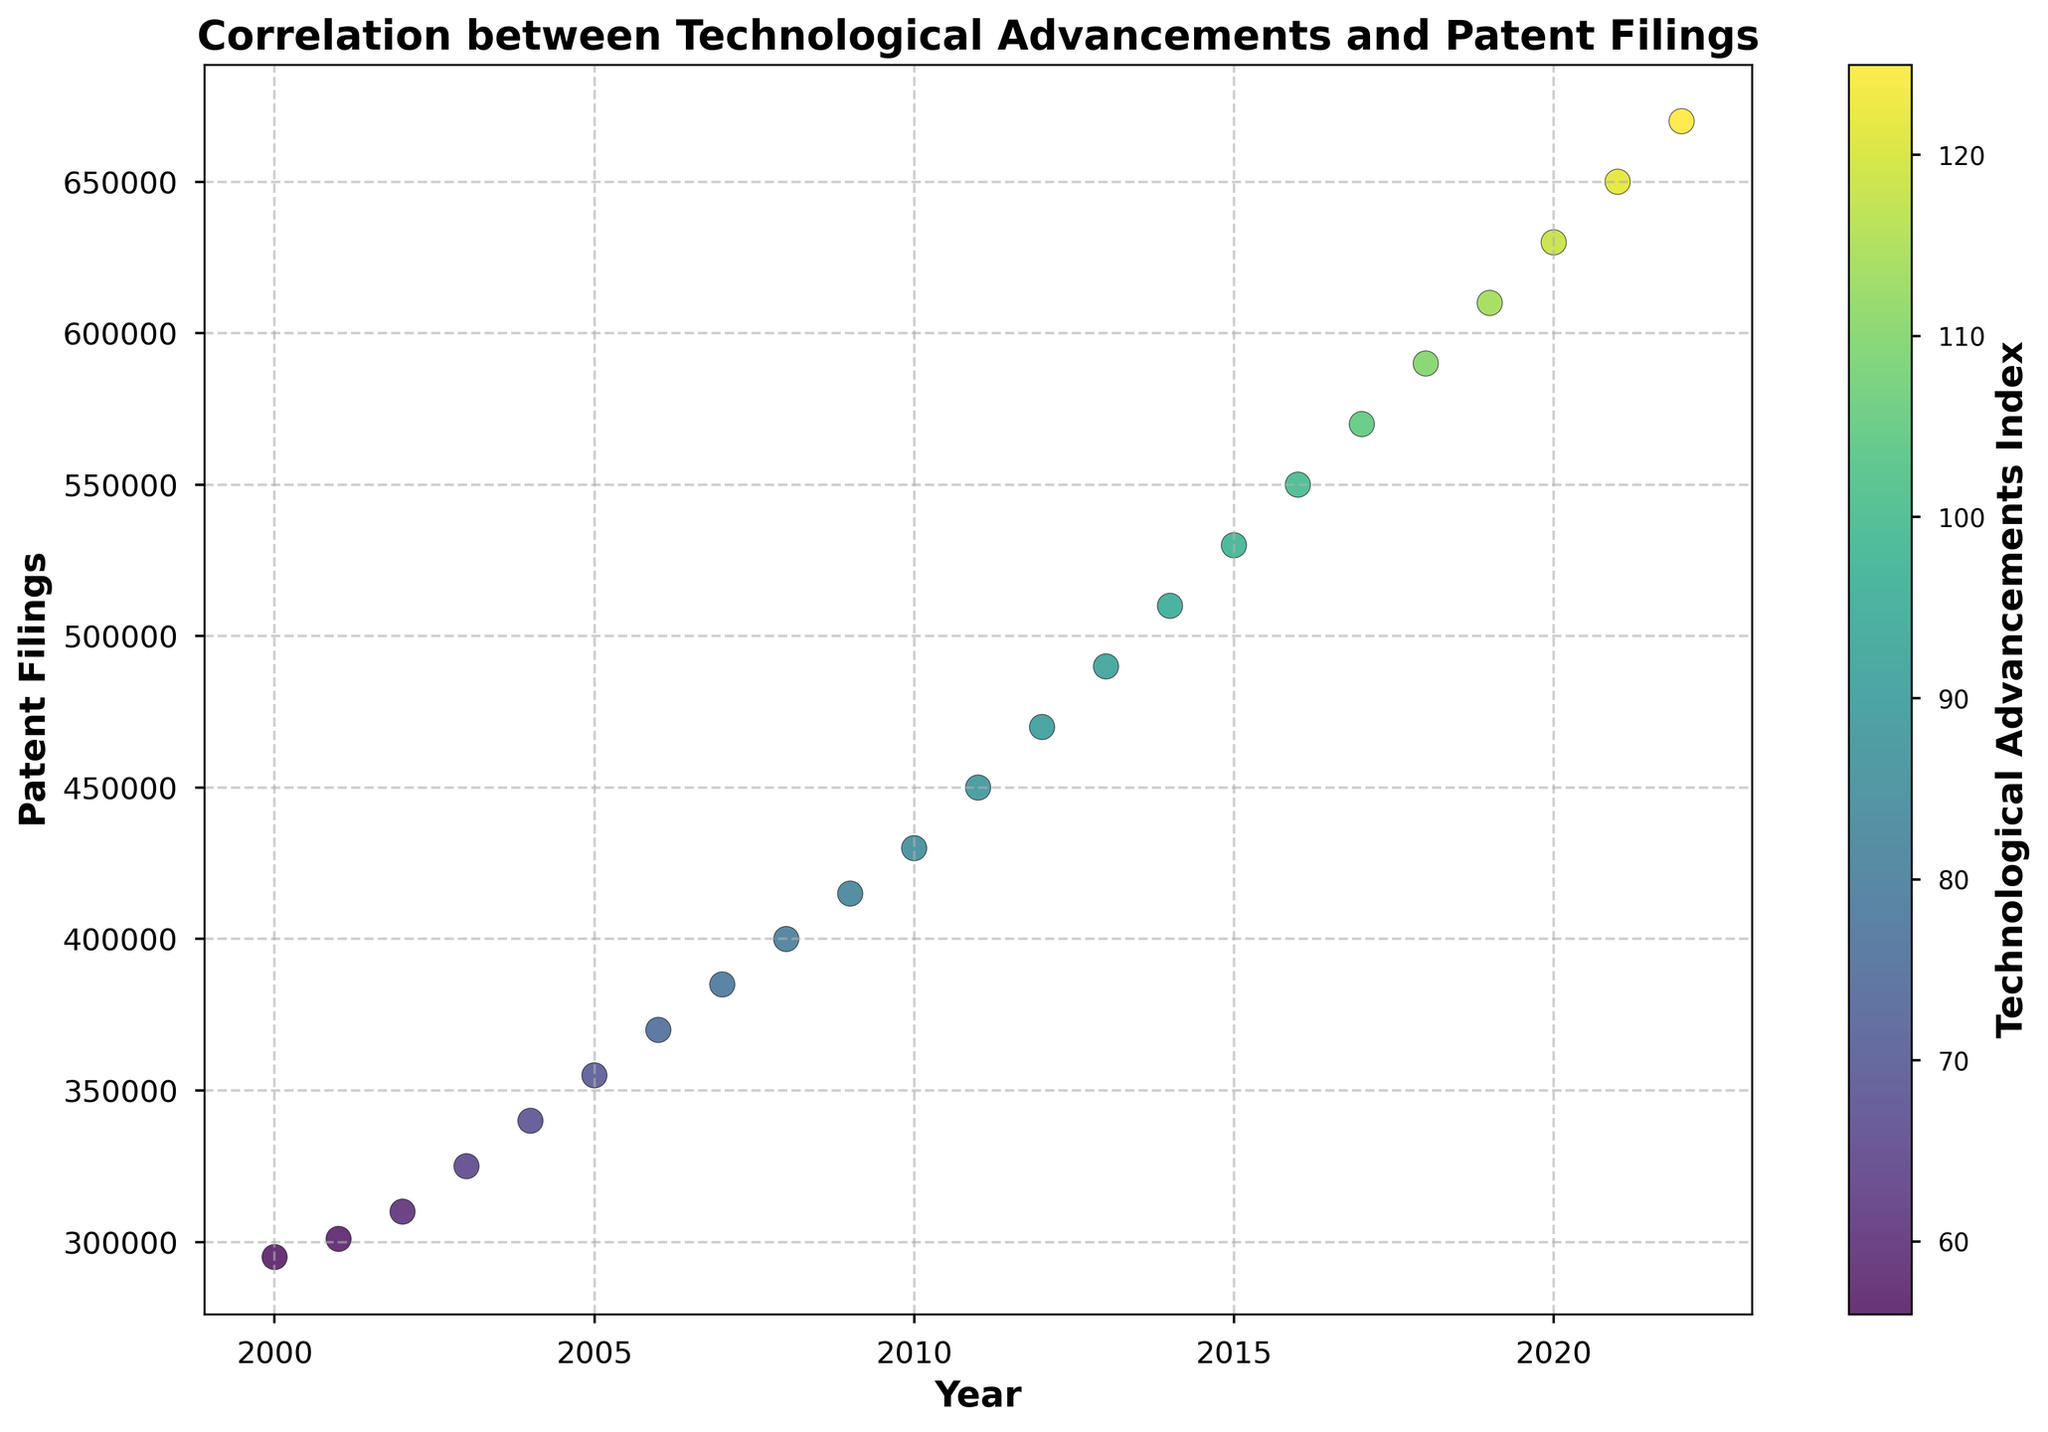What is the overall trend in patent filings from 2000 to 2022? By examining the plot, we observe that the points, which represent patent filings over time, demonstrate an upward trajectory from 2000 to 2022. This indicates that the number of patent filings increased consistently over the years.
Answer: Increasing What is the correlation between the technological advancements index and patent filings? The color gradient of the scatter plot points, according to the colorbar, shows that as the technological advancements index increases (moving toward a more yellow color), the number of patent filings also increases. This indicates a positive correlation between technological advancements and patent filings.
Answer: Positive correlation How do patent filings in 2010 compare to those in 2020? By locating the points for 2010 and 2020 on the x-axis and comparing their y-values (patent filings), we see that patent filings in 2010 are at approximately 430,000, whereas in 2020, they are at approximately 630,000. Thus, patent filings in 2020 are significantly higher than in 2010.
Answer: Higher in 2020 What is the difference in patent filings between the years with the lowest and highest technological advancements index? The lowest technological advancements index is 56 (in 2000), and the highest is 125 (in 2022). Looking at their corresponding patent filings, 2000 has 295,000 filings, and 2022 has 670,000 filings. The difference is 670,000 - 295,000 = 375,000.
Answer: 375,000 Which year saw the highest number of patent filings? By examining the y-axis values of the scatter points, the highest patent filings are associated with the highest point, which is in the year 2022, with approximately 670,000 filings.
Answer: 2022 How does the technological advancements index change from 2015 to 2020? We observe the color of the points for 2015 and 2020 and refer to the colorbar. In 2015, the index is 98 (lighter green), and in 2020, it is 118 (yellowish). This shows an increase in the technological advancements index from 2015 to 2020.
Answer: Increases What is the average number of patent filings from 2000 to 2022? To find the average, we sum the patent filings from all the years and divide by the number of years. (295,000 + 301,000 + 310,000 + 325,000 + 340,000 + 355,000 + 370,000 + 385,000 + 400,000 + 415,000 + 430,000 + 450,000 + 470,000 + 490,000 + 510,000 + 530,000 + 550,000 + 570,000 + 590,000 + 610,000 + 630,000 + 650,000 + 670,000) / 23 ≈ 460,217 patent filings.
Answer: 460,217 By how much did patent filings increase per year on average from 2000 to 2010? First, find the increase in patent filings from 2000 (295,000) to 2010 (430,000): 430,000 - 295,000 = 135,000. Then divide by the number of years: 135,000 / 10 = 13,500 filings per year.
Answer: 13,500 filings per year 